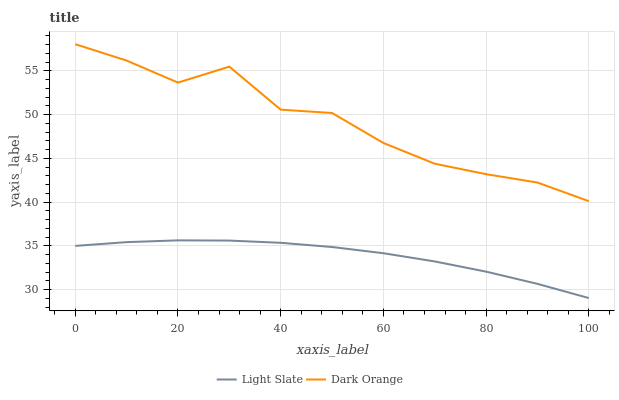Does Light Slate have the minimum area under the curve?
Answer yes or no. Yes. Does Dark Orange have the maximum area under the curve?
Answer yes or no. Yes. Does Dark Orange have the minimum area under the curve?
Answer yes or no. No. Is Light Slate the smoothest?
Answer yes or no. Yes. Is Dark Orange the roughest?
Answer yes or no. Yes. Is Dark Orange the smoothest?
Answer yes or no. No. Does Light Slate have the lowest value?
Answer yes or no. Yes. Does Dark Orange have the lowest value?
Answer yes or no. No. Does Dark Orange have the highest value?
Answer yes or no. Yes. Is Light Slate less than Dark Orange?
Answer yes or no. Yes. Is Dark Orange greater than Light Slate?
Answer yes or no. Yes. Does Light Slate intersect Dark Orange?
Answer yes or no. No. 